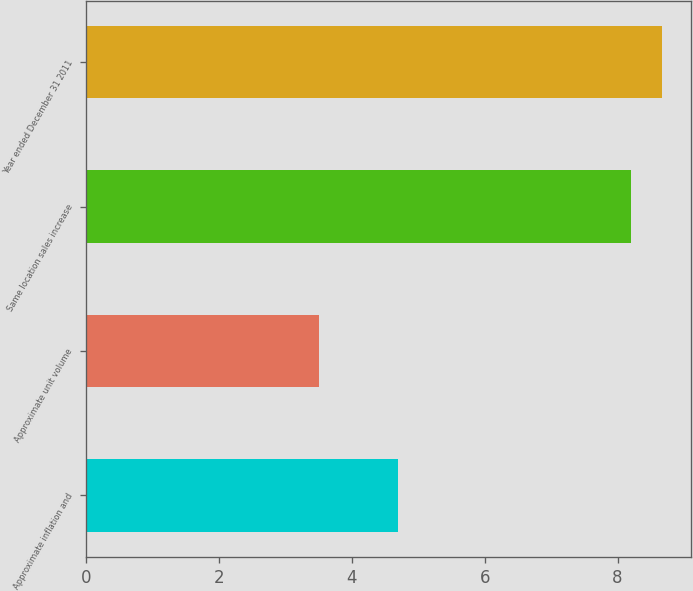Convert chart. <chart><loc_0><loc_0><loc_500><loc_500><bar_chart><fcel>Approximate inflation and<fcel>Approximate unit volume<fcel>Same location sales increase<fcel>Year ended December 31 2011<nl><fcel>4.7<fcel>3.5<fcel>8.2<fcel>8.67<nl></chart> 